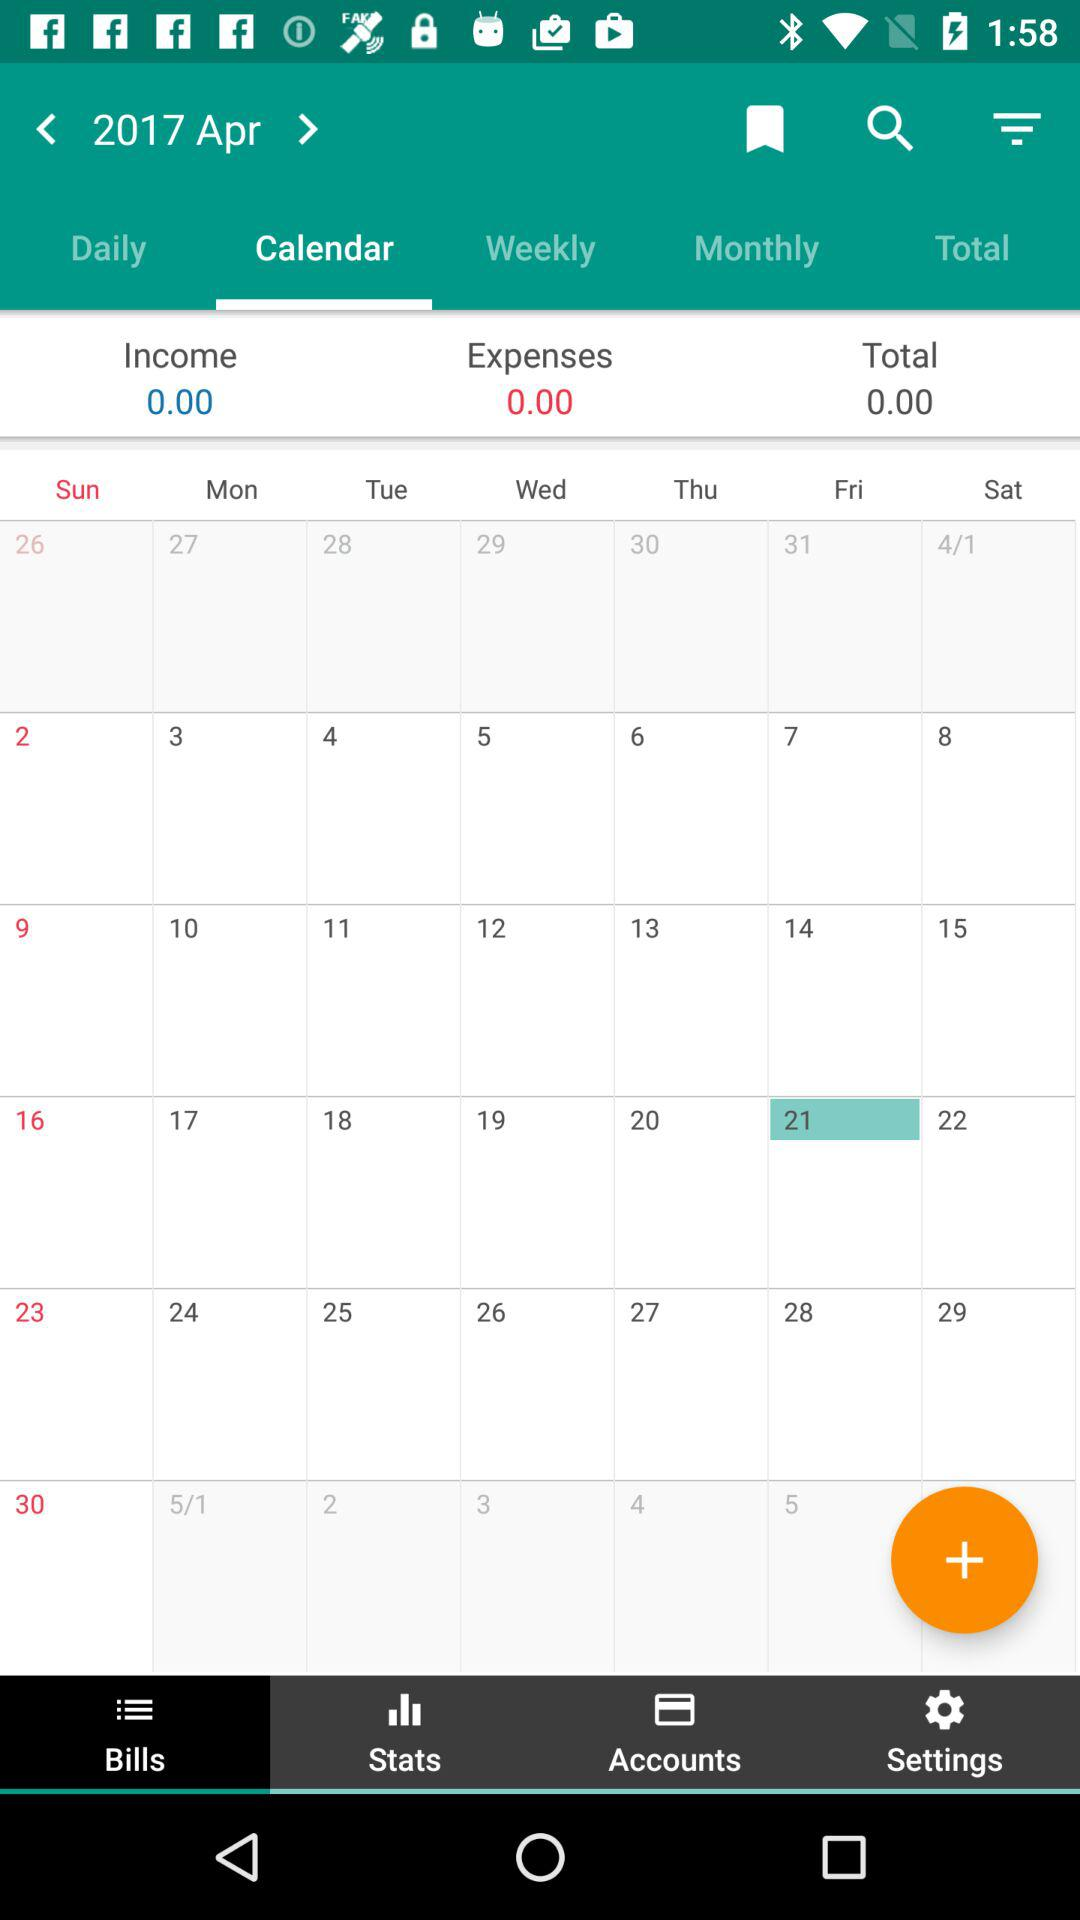Which year is shown? The shown year is 2017. 